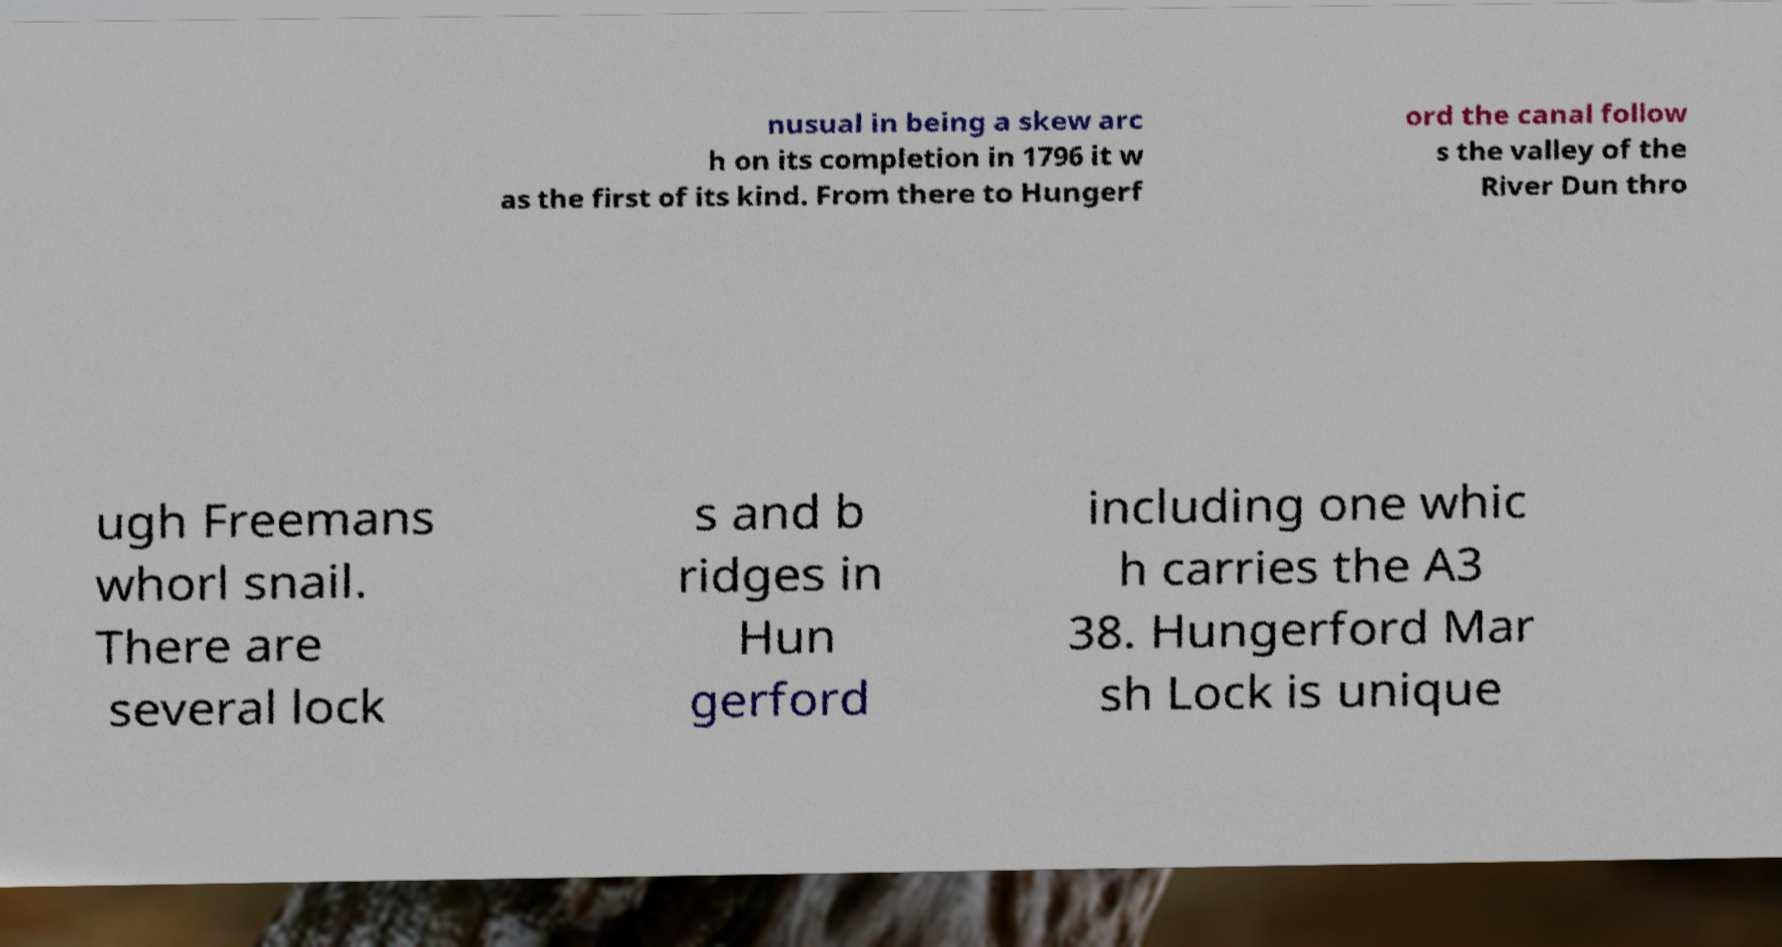I need the written content from this picture converted into text. Can you do that? nusual in being a skew arc h on its completion in 1796 it w as the first of its kind. From there to Hungerf ord the canal follow s the valley of the River Dun thro ugh Freemans whorl snail. There are several lock s and b ridges in Hun gerford including one whic h carries the A3 38. Hungerford Mar sh Lock is unique 